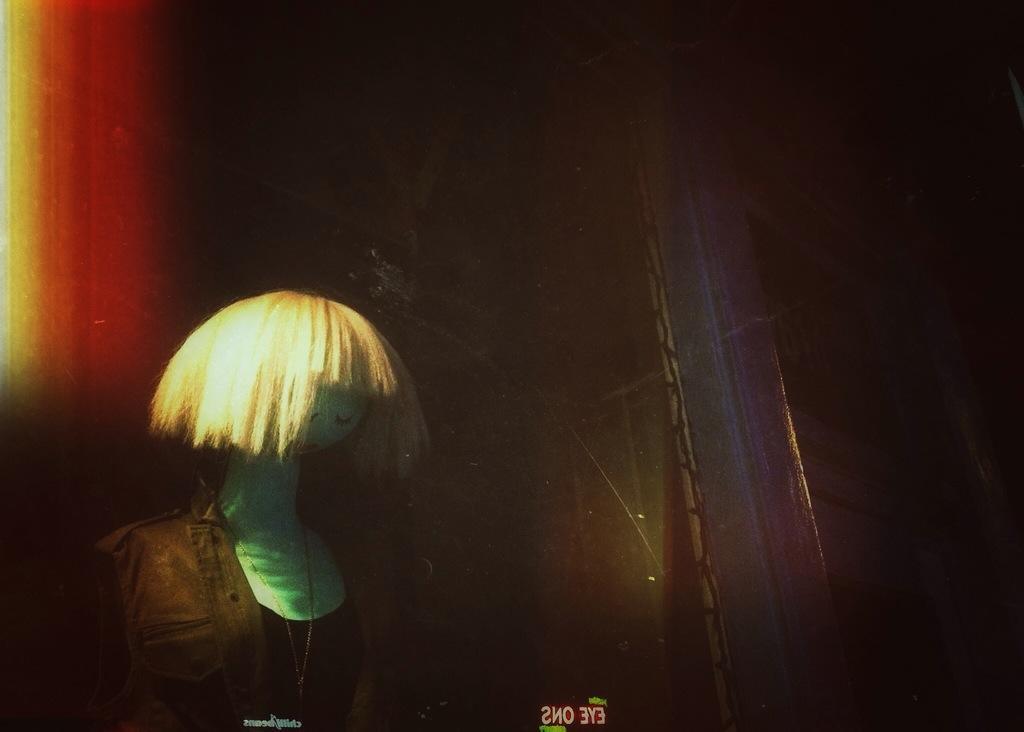Can you describe this image briefly? In this image I can see the mannequin with the dress. I can see the dress is in brown and black color. And there is a dark background. 